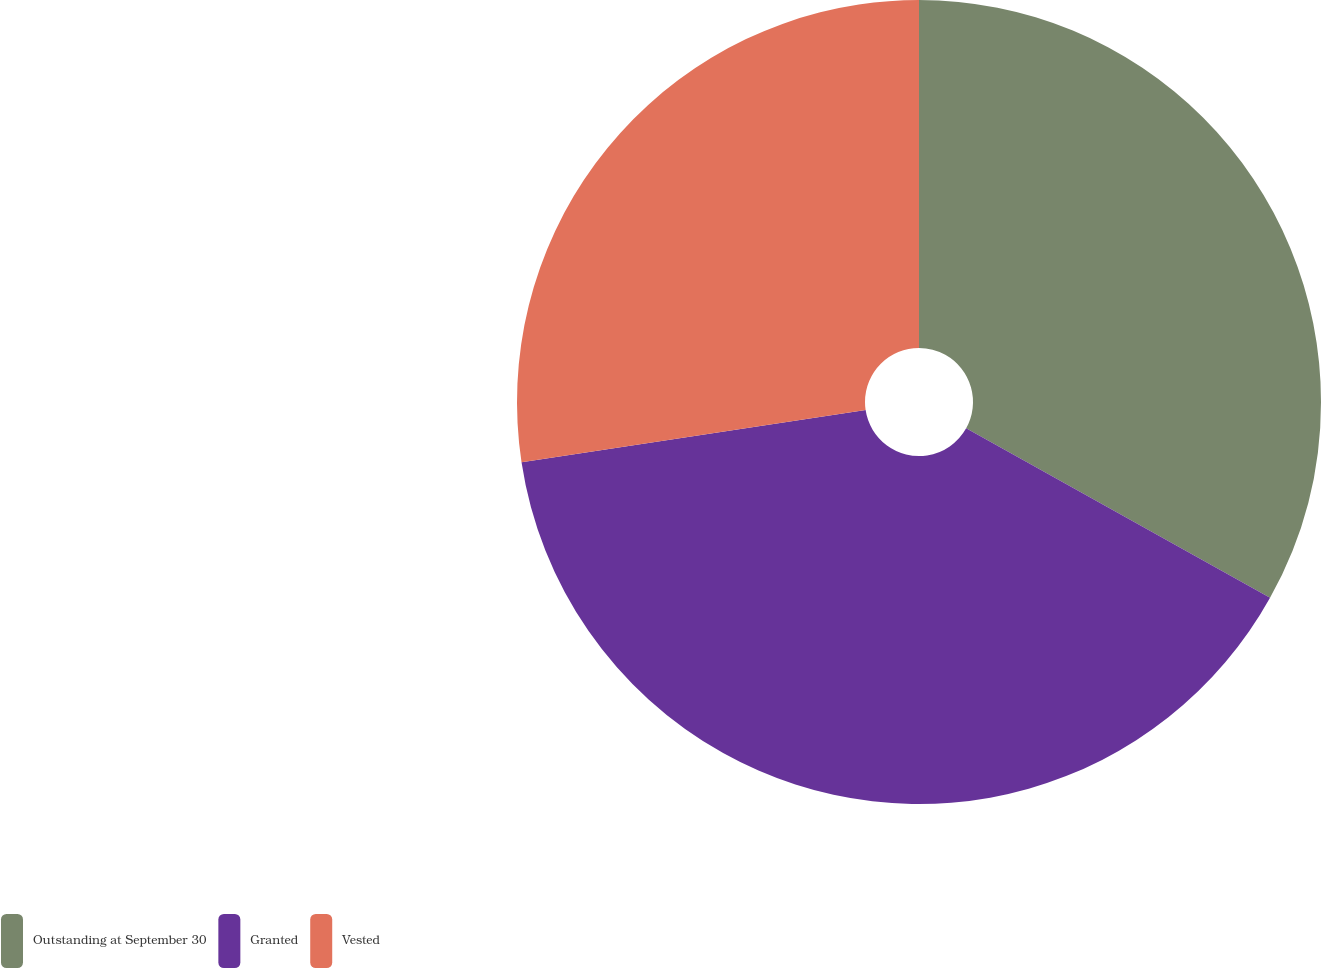Convert chart to OTSL. <chart><loc_0><loc_0><loc_500><loc_500><pie_chart><fcel>Outstanding at September 30<fcel>Granted<fcel>Vested<nl><fcel>33.1%<fcel>39.51%<fcel>27.39%<nl></chart> 